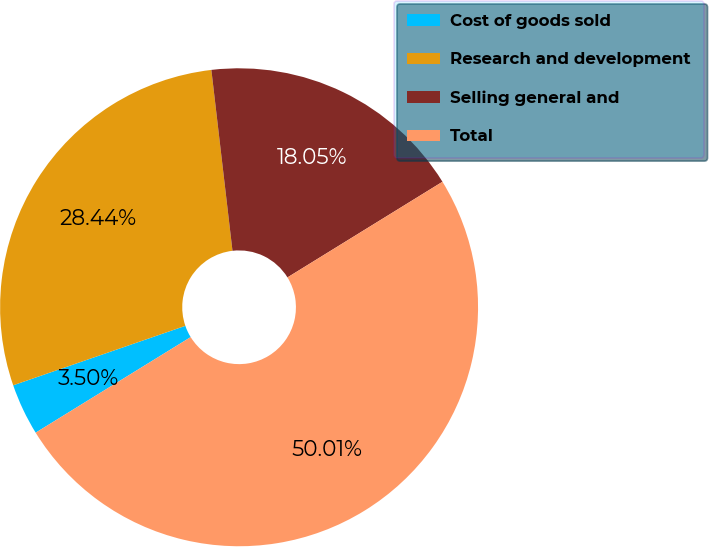<chart> <loc_0><loc_0><loc_500><loc_500><pie_chart><fcel>Cost of goods sold<fcel>Research and development<fcel>Selling general and<fcel>Total<nl><fcel>3.5%<fcel>28.44%<fcel>18.05%<fcel>50.0%<nl></chart> 